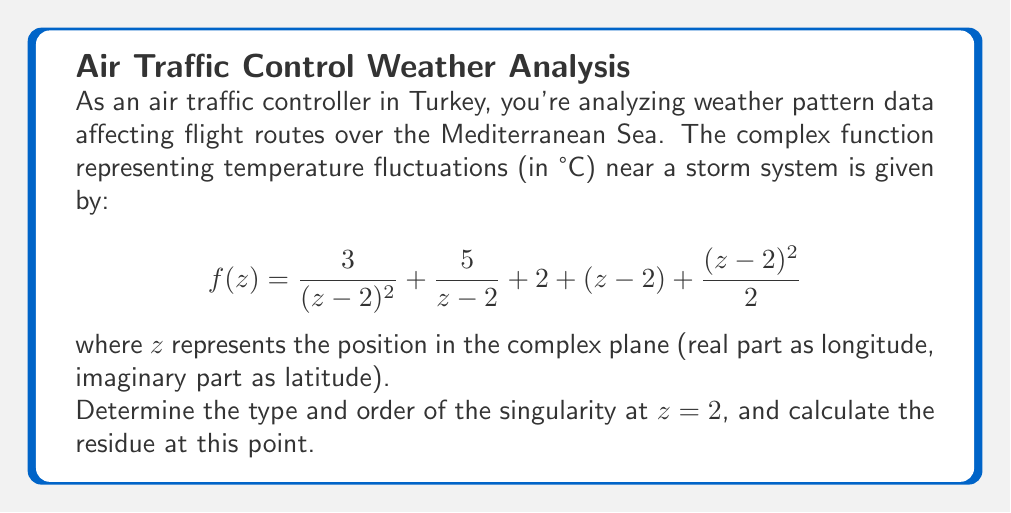Can you answer this question? To analyze the singularity at $z=2$, we need to examine the Laurent series of the function around this point:

1) The given function is already in the form of a Laurent series around $z=2$:

   $$f(z) = \frac{3}{(z-2)^2} + \frac{5}{z-2} + 2 + (z-2) + \frac{(z-2)^2}{2}$$

2) Identify the terms:
   - $\frac{3}{(z-2)^2}$ is the term with $(z-2)^{-2}$
   - $\frac{5}{z-2}$ is the term with $(z-2)^{-1}$
   - $2$ is the constant term
   - $(z-2)$ is the term with $(z-2)^1$
   - $\frac{(z-2)^2}{2}$ is the term with $(z-2)^2$

3) The singularity type is determined by the most negative power of $(z-2)$:
   - The most negative power is -2
   - This indicates a pole of order 2

4) To calculate the residue, we need the coefficient of $(z-2)^{-1}$ in the Laurent series:
   - The coefficient of $(z-2)^{-1}$ is 5

Therefore, the singularity at $z=2$ is a pole of order 2, and the residue is 5.
Answer: Pole of order 2; Residue = 5 